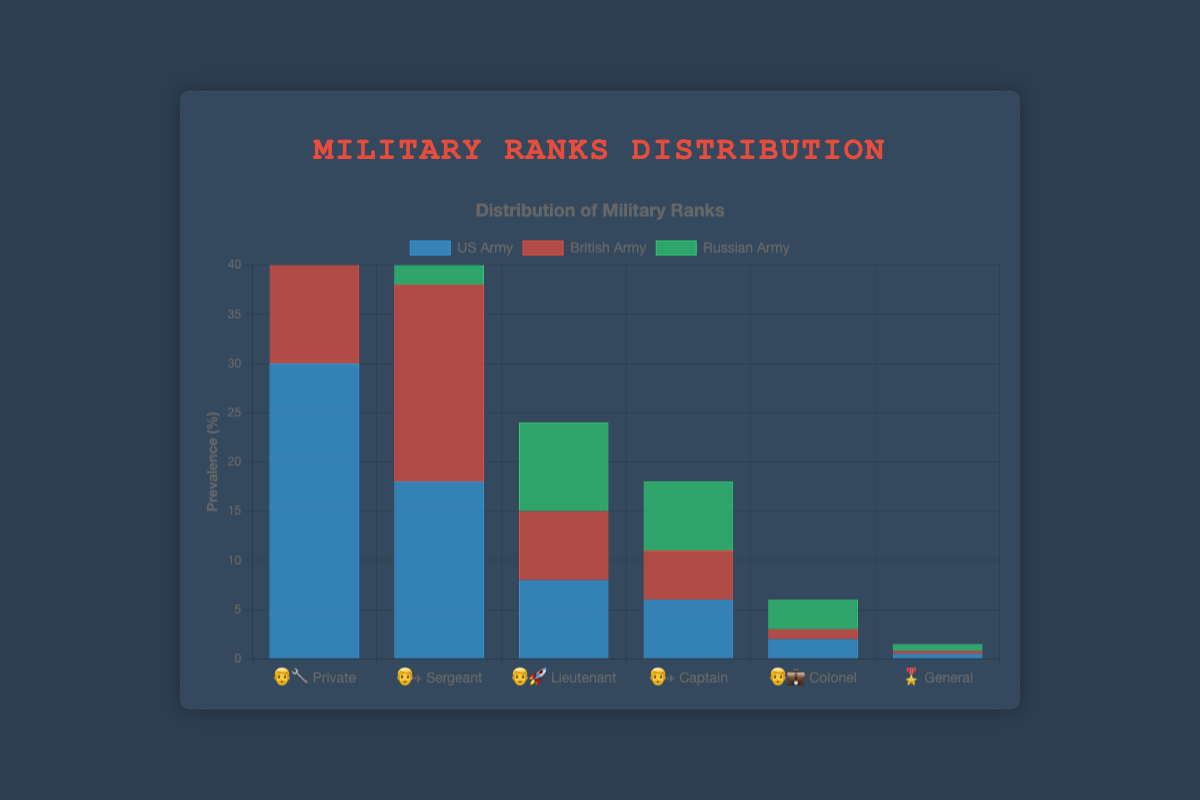What is the most common rank in the Russian Army? The most common rank in the Russian Army can be identified by looking at the data where the prevalence percentage is the highest. The rank "Private" with an emoji 👨‍🔧 has the highest prevalence at 35%.
Answer: Private Which rank appears more in the British Army compared to the US Army? To find this, compare the prevalence percentages of each rank between the British Army and the US Army. For "Sergeant" (👨‍✈️), the British Army has 20%, which is higher than the 18% in the US Army.
Answer: Sergeant What is the total prevalence of the "Captain" rank across all three armies? Add the prevalence percentages of Captains in the US Army (6%), British Army (5%), and Russian Army (7%). So, the total prevalence is 6 + 5 + 7 = 18%.
Answer: 18% Which rank has the least prevalence in the US Army? Look at the data for each rank's prevalence in the US Army. The "General" rank (🎖️) has the least prevalence at 0.5%.
Answer: General How does the prevalence of "Colonel" in the Russian Army compare to the British Army? Compare the prevalence percentages for Colonels. The Russian Army has 3%, while the British Army has 1%, so the prevalence is higher in the Russian Army.
Answer: Russian Army has higher prevalence What is the average prevalence of all ranks in the British Army? Sum all the prevalence percentages in the British Army and divide by the number of ranks. (28 + 20 + 7 + 5 + 1 + 0.3) / 6 = 61.3 / 6 = 10.22%.
Answer: 10.22% Which army has the highest prevalence of "Lieutenant"? Compare the prevalence percentages of the "Lieutenant" rank for each army. The Russian Army has the highest at 9%.
Answer: Russian Army How much greater is the prevalence of "Private" in the Russian Army compared to the British Army? Subtract the prevalence of the "Private" rank in the British Army (28%) from the Russian Army (35%). 35 - 28 = 7%.
Answer: 7% 